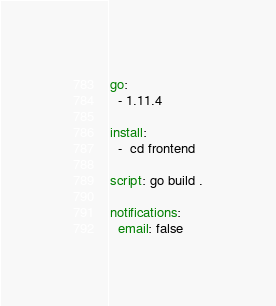<code> <loc_0><loc_0><loc_500><loc_500><_YAML_>
go:
  - 1.11.4

install:
  -  cd frontend

script: go build .

notifications:
  email: false</code> 